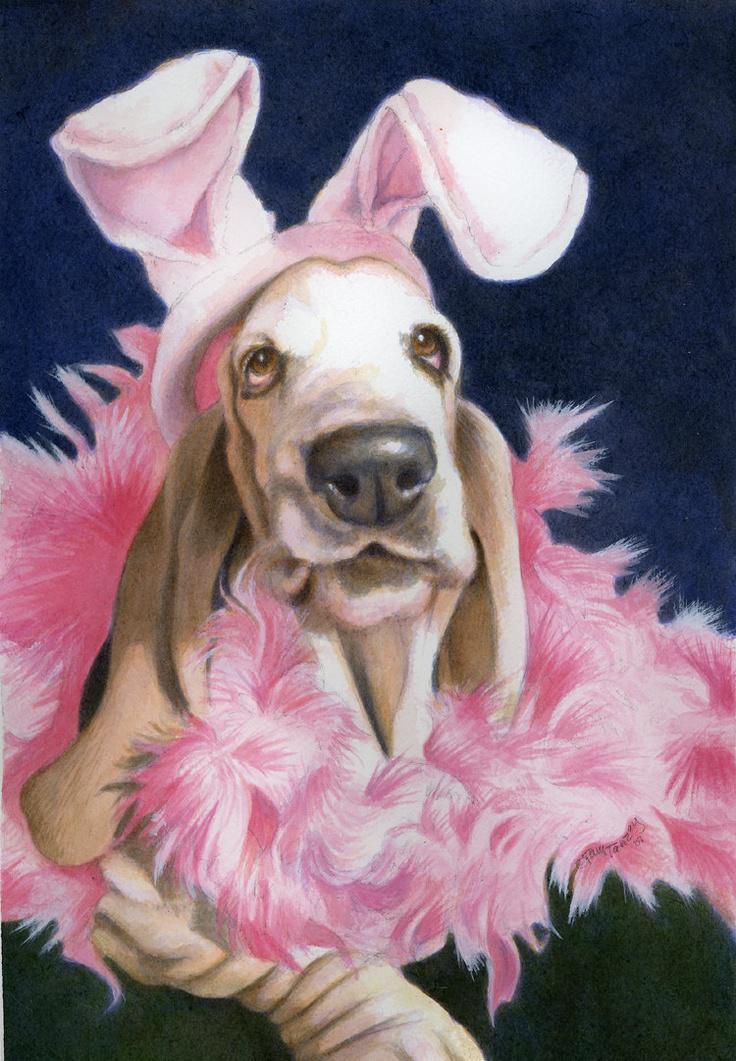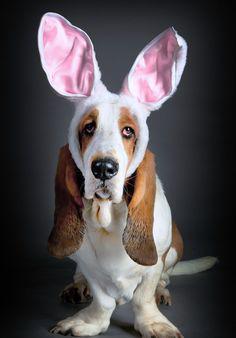The first image is the image on the left, the second image is the image on the right. For the images shown, is this caption "there is only one dog in the image on the left side and it is not wearing bunny ears." true? Answer yes or no. No. The first image is the image on the left, the second image is the image on the right. For the images shown, is this caption "A real basset hound is wearing rabbit hears." true? Answer yes or no. Yes. 